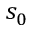<formula> <loc_0><loc_0><loc_500><loc_500>s _ { 0 }</formula> 